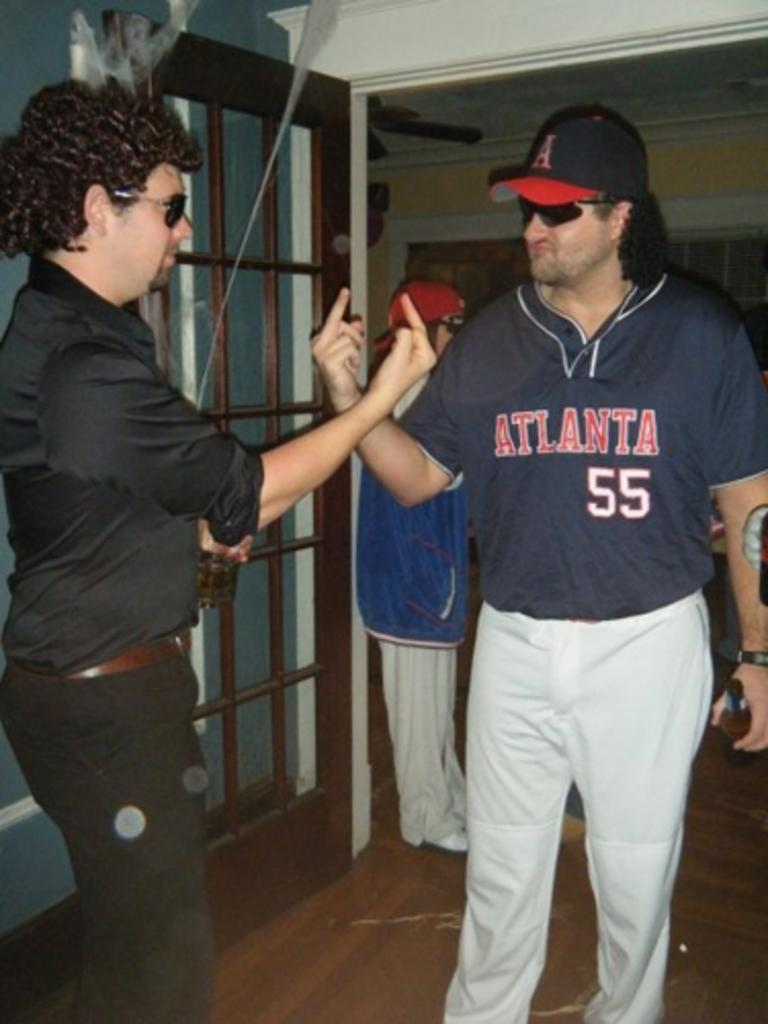<image>
Write a terse but informative summary of the picture. Player number 55 from Atlanta is giving someone the finger. 